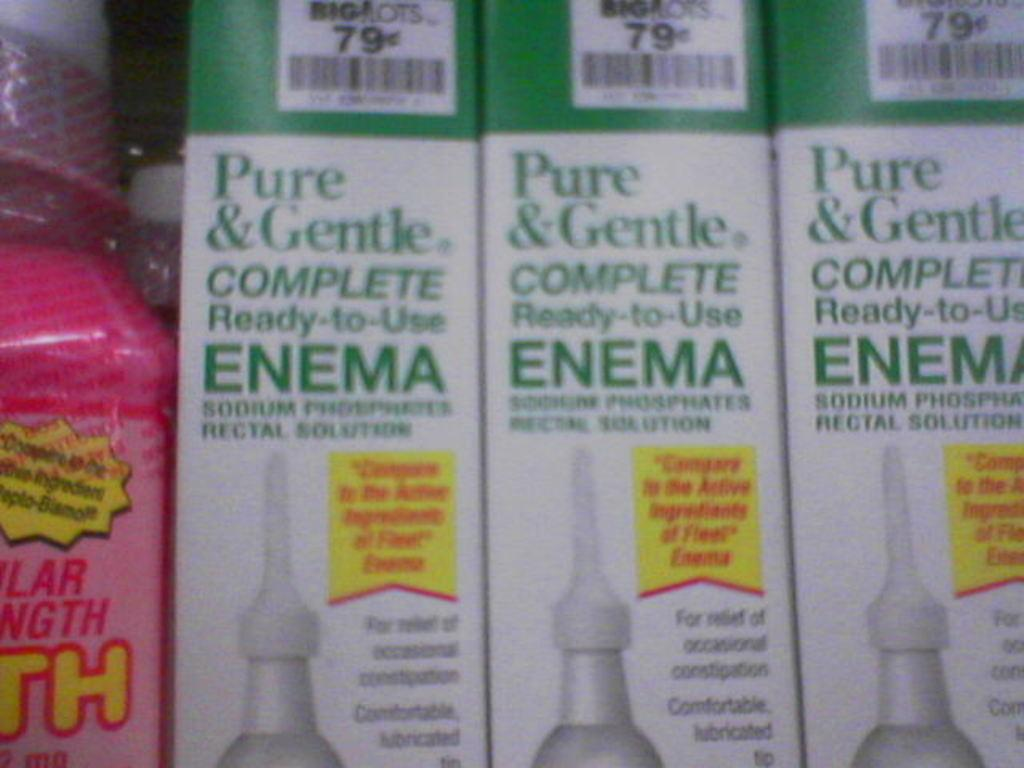<image>
Share a concise interpretation of the image provided. Three packages of 79 cent enemas for sale.. 